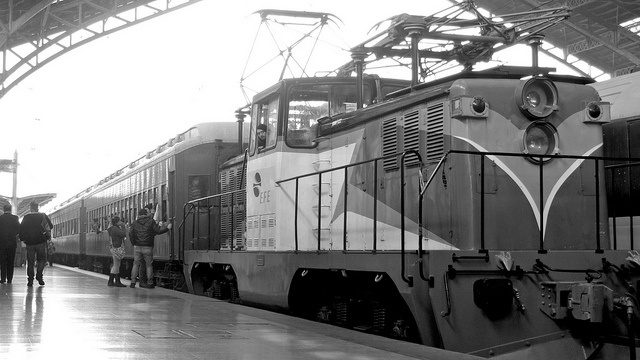Describe the objects in this image and their specific colors. I can see train in gray, black, darkgray, and lightgray tones, people in gray, black, darkgray, and lightgray tones, people in gray and black tones, people in gray, black, darkgray, and lightgray tones, and people in gray, black, and lightgray tones in this image. 